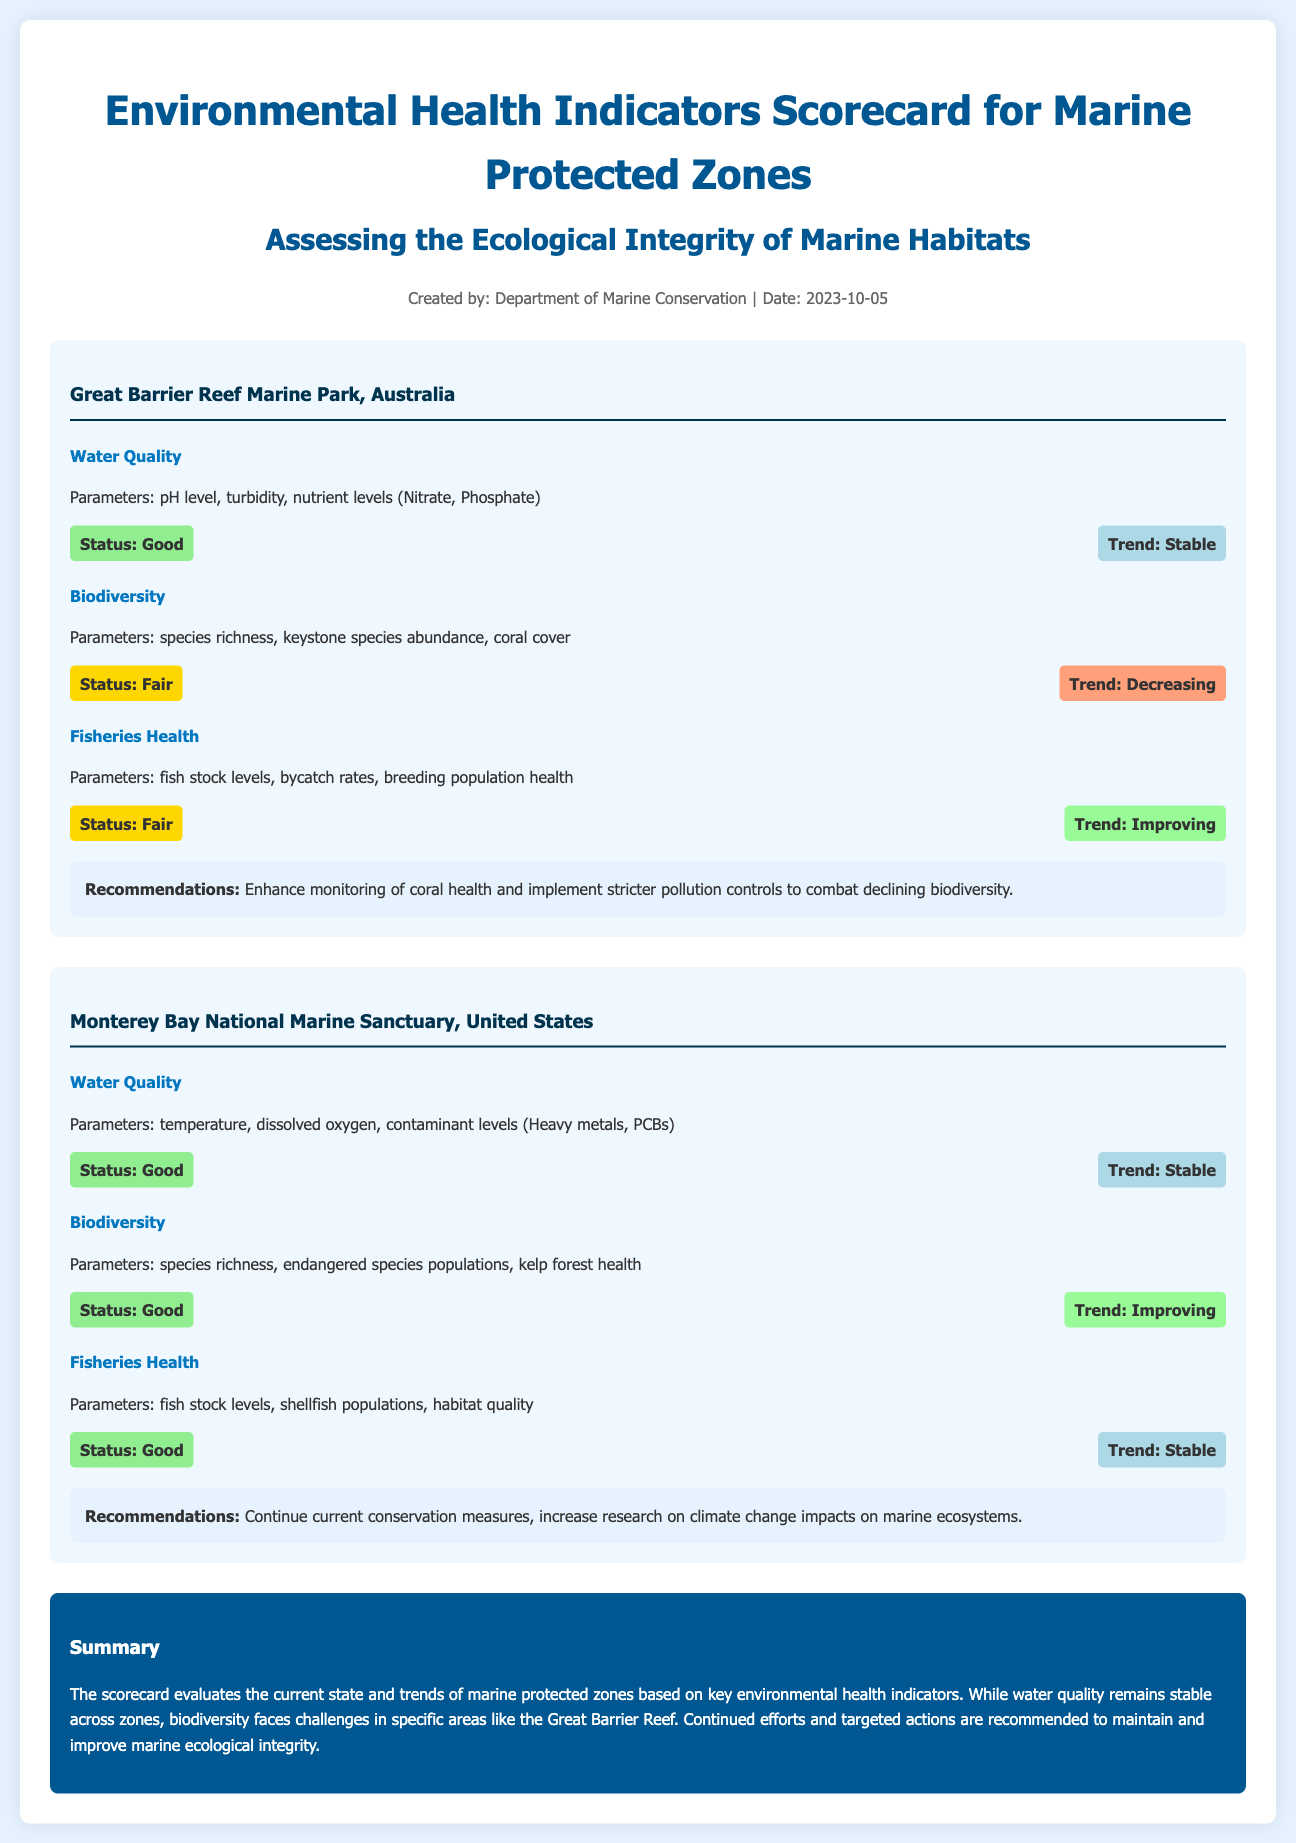what is the title of the document? The title is stated at the top of the document and indicates the focus of the content.
Answer: Environmental Health Indicators Scorecard for Marine Protected Zones who created the document? The creator of the document is mentioned in the meta-info section.
Answer: Department of Marine Conservation when was the document created? The creation date is also provided in the meta-info section of the document.
Answer: 2023-10-05 what is the status of water quality in the Great Barrier Reef Marine Park? The document specifies the current status of water quality for each zone listed.
Answer: Good what trend is observed in biodiversity for the Great Barrier Reef Marine Park? The trend in biodiversity is indicated under the biodiversity indicator for the specific zone.
Answer: Decreasing what are the recommendations for the Monterey Bay National Marine Sanctuary? The recommendations are summarized for each zone and provide actions to be taken.
Answer: Continue current conservation measures, increase research on climate change impacts on marine ecosystems how many indicators are assessed for the Monterey Bay National Marine Sanctuary? The total number of indicators listed for each zone is mentioned in the respective sections.
Answer: Three which marine protected zone has a declining trend in biodiversity? The trend for biodiversity is compared between the zones, identifying which has problems.
Answer: Great Barrier Reef Marine Park what parameter is included in the fisheries health indicator for the Great Barrier Reef Marine Park? The document lists specific parameters that are assessed under each indicator for accurate monitoring.
Answer: fish stock levels 